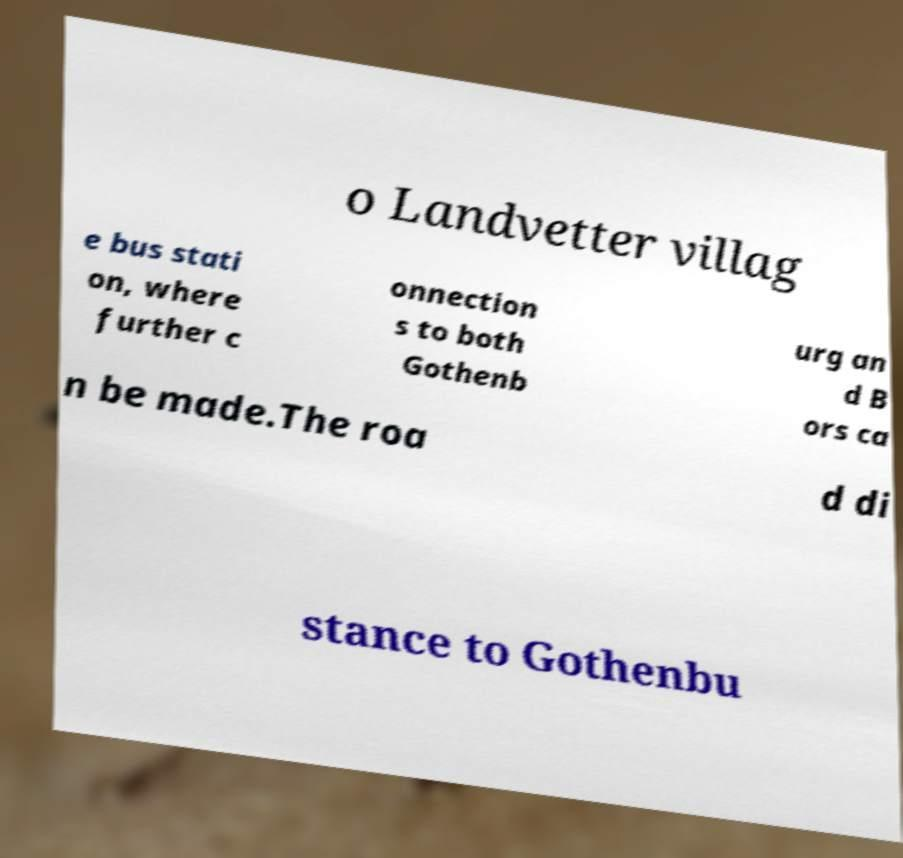For documentation purposes, I need the text within this image transcribed. Could you provide that? o Landvetter villag e bus stati on, where further c onnection s to both Gothenb urg an d B ors ca n be made.The roa d di stance to Gothenbu 